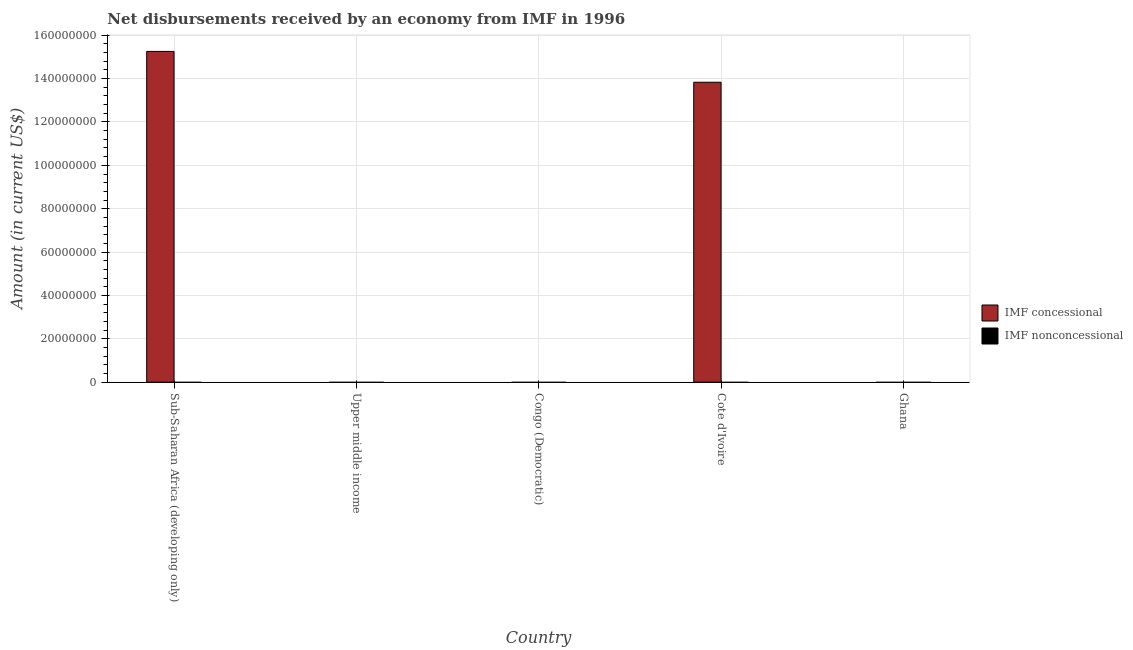How many different coloured bars are there?
Ensure brevity in your answer.  1. Are the number of bars per tick equal to the number of legend labels?
Offer a very short reply. No. Are the number of bars on each tick of the X-axis equal?
Provide a succinct answer. No. How many bars are there on the 5th tick from the right?
Give a very brief answer. 1. What is the label of the 4th group of bars from the left?
Your answer should be very brief. Cote d'Ivoire. What is the net concessional disbursements from imf in Sub-Saharan Africa (developing only)?
Ensure brevity in your answer.  1.53e+08. Across all countries, what is the maximum net concessional disbursements from imf?
Offer a terse response. 1.53e+08. Across all countries, what is the minimum net concessional disbursements from imf?
Your response must be concise. 0. In which country was the net concessional disbursements from imf maximum?
Your answer should be very brief. Sub-Saharan Africa (developing only). What is the difference between the net non concessional disbursements from imf in Congo (Democratic) and the net concessional disbursements from imf in Cote d'Ivoire?
Give a very brief answer. -1.38e+08. In how many countries, is the net non concessional disbursements from imf greater than 116000000 US$?
Your answer should be very brief. 0. What is the difference between the highest and the lowest net concessional disbursements from imf?
Your answer should be very brief. 1.53e+08. How many bars are there?
Ensure brevity in your answer.  2. What is the difference between two consecutive major ticks on the Y-axis?
Provide a short and direct response. 2.00e+07. Does the graph contain any zero values?
Ensure brevity in your answer.  Yes. Where does the legend appear in the graph?
Offer a terse response. Center right. What is the title of the graph?
Offer a terse response. Net disbursements received by an economy from IMF in 1996. Does "National Tourists" appear as one of the legend labels in the graph?
Keep it short and to the point. No. What is the label or title of the X-axis?
Offer a terse response. Country. What is the Amount (in current US$) of IMF concessional in Sub-Saharan Africa (developing only)?
Give a very brief answer. 1.53e+08. What is the Amount (in current US$) in IMF nonconcessional in Sub-Saharan Africa (developing only)?
Ensure brevity in your answer.  0. What is the Amount (in current US$) in IMF concessional in Upper middle income?
Your answer should be compact. 0. What is the Amount (in current US$) of IMF concessional in Cote d'Ivoire?
Keep it short and to the point. 1.38e+08. Across all countries, what is the maximum Amount (in current US$) in IMF concessional?
Your response must be concise. 1.53e+08. Across all countries, what is the minimum Amount (in current US$) in IMF concessional?
Offer a very short reply. 0. What is the total Amount (in current US$) in IMF concessional in the graph?
Your answer should be very brief. 2.91e+08. What is the difference between the Amount (in current US$) in IMF concessional in Sub-Saharan Africa (developing only) and that in Cote d'Ivoire?
Your answer should be very brief. 1.42e+07. What is the average Amount (in current US$) in IMF concessional per country?
Offer a terse response. 5.82e+07. What is the average Amount (in current US$) in IMF nonconcessional per country?
Your answer should be compact. 0. What is the ratio of the Amount (in current US$) in IMF concessional in Sub-Saharan Africa (developing only) to that in Cote d'Ivoire?
Your response must be concise. 1.1. What is the difference between the highest and the lowest Amount (in current US$) in IMF concessional?
Ensure brevity in your answer.  1.53e+08. 